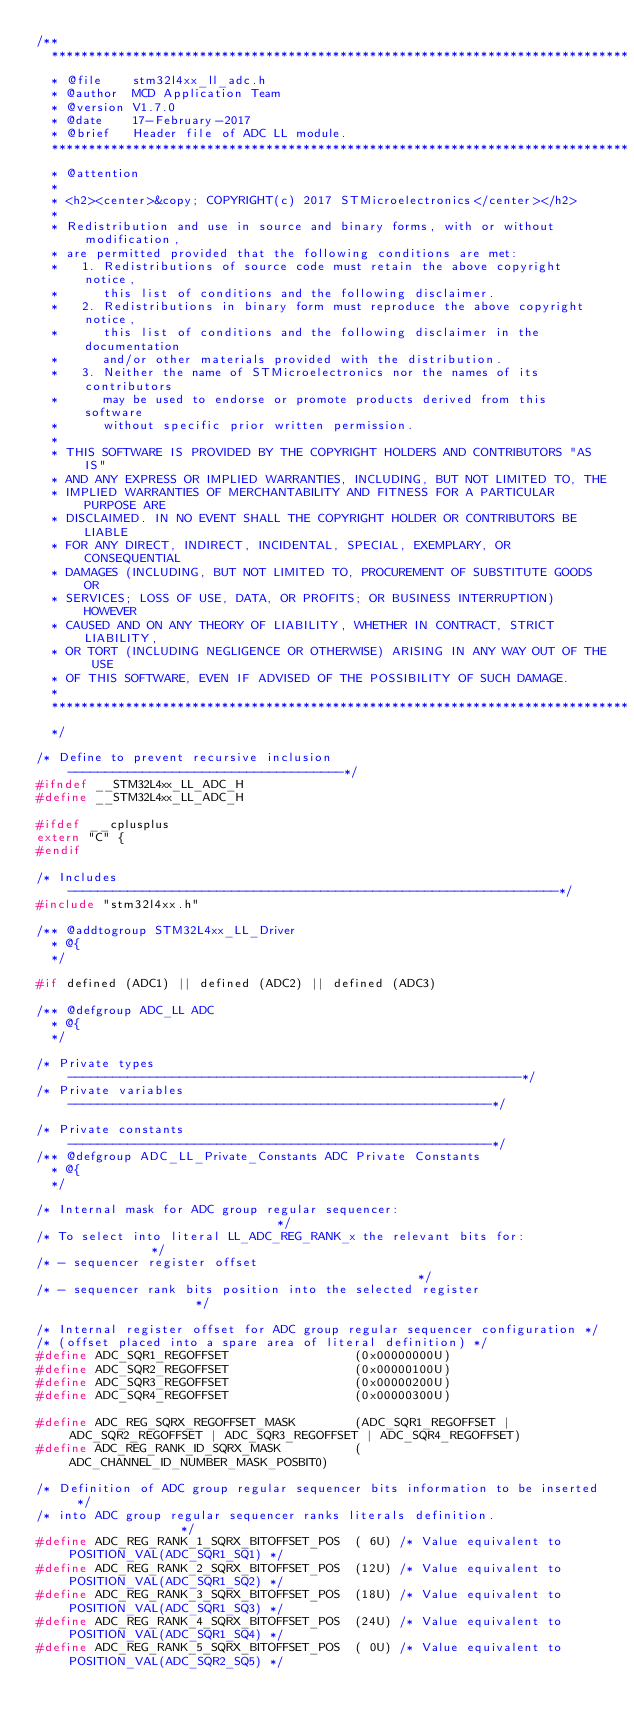Convert code to text. <code><loc_0><loc_0><loc_500><loc_500><_C_>/**
  ******************************************************************************
  * @file    stm32l4xx_ll_adc.h
  * @author  MCD Application Team
  * @version V1.7.0
  * @date    17-February-2017
  * @brief   Header file of ADC LL module.
  ******************************************************************************
  * @attention
  *
  * <h2><center>&copy; COPYRIGHT(c) 2017 STMicroelectronics</center></h2>
  *
  * Redistribution and use in source and binary forms, with or without modification,
  * are permitted provided that the following conditions are met:
  *   1. Redistributions of source code must retain the above copyright notice,
  *      this list of conditions and the following disclaimer.
  *   2. Redistributions in binary form must reproduce the above copyright notice,
  *      this list of conditions and the following disclaimer in the documentation
  *      and/or other materials provided with the distribution.
  *   3. Neither the name of STMicroelectronics nor the names of its contributors
  *      may be used to endorse or promote products derived from this software
  *      without specific prior written permission.
  *
  * THIS SOFTWARE IS PROVIDED BY THE COPYRIGHT HOLDERS AND CONTRIBUTORS "AS IS"
  * AND ANY EXPRESS OR IMPLIED WARRANTIES, INCLUDING, BUT NOT LIMITED TO, THE
  * IMPLIED WARRANTIES OF MERCHANTABILITY AND FITNESS FOR A PARTICULAR PURPOSE ARE
  * DISCLAIMED. IN NO EVENT SHALL THE COPYRIGHT HOLDER OR CONTRIBUTORS BE LIABLE
  * FOR ANY DIRECT, INDIRECT, INCIDENTAL, SPECIAL, EXEMPLARY, OR CONSEQUENTIAL
  * DAMAGES (INCLUDING, BUT NOT LIMITED TO, PROCUREMENT OF SUBSTITUTE GOODS OR
  * SERVICES; LOSS OF USE, DATA, OR PROFITS; OR BUSINESS INTERRUPTION) HOWEVER
  * CAUSED AND ON ANY THEORY OF LIABILITY, WHETHER IN CONTRACT, STRICT LIABILITY,
  * OR TORT (INCLUDING NEGLIGENCE OR OTHERWISE) ARISING IN ANY WAY OUT OF THE USE
  * OF THIS SOFTWARE, EVEN IF ADVISED OF THE POSSIBILITY OF SUCH DAMAGE.
  *
  ******************************************************************************
  */

/* Define to prevent recursive inclusion -------------------------------------*/
#ifndef __STM32L4xx_LL_ADC_H
#define __STM32L4xx_LL_ADC_H

#ifdef __cplusplus
extern "C" {
#endif

/* Includes ------------------------------------------------------------------*/
#include "stm32l4xx.h"

/** @addtogroup STM32L4xx_LL_Driver
  * @{
  */

#if defined (ADC1) || defined (ADC2) || defined (ADC3)

/** @defgroup ADC_LL ADC
  * @{
  */

/* Private types -------------------------------------------------------------*/
/* Private variables ---------------------------------------------------------*/

/* Private constants ---------------------------------------------------------*/
/** @defgroup ADC_LL_Private_Constants ADC Private Constants
  * @{
  */

/* Internal mask for ADC group regular sequencer:                             */
/* To select into literal LL_ADC_REG_RANK_x the relevant bits for:            */
/* - sequencer register offset                                                */
/* - sequencer rank bits position into the selected register                  */

/* Internal register offset for ADC group regular sequencer configuration */
/* (offset placed into a spare area of literal definition) */
#define ADC_SQR1_REGOFFSET                 (0x00000000U)
#define ADC_SQR2_REGOFFSET                 (0x00000100U)
#define ADC_SQR3_REGOFFSET                 (0x00000200U)
#define ADC_SQR4_REGOFFSET                 (0x00000300U)

#define ADC_REG_SQRX_REGOFFSET_MASK        (ADC_SQR1_REGOFFSET | ADC_SQR2_REGOFFSET | ADC_SQR3_REGOFFSET | ADC_SQR4_REGOFFSET)
#define ADC_REG_RANK_ID_SQRX_MASK          (ADC_CHANNEL_ID_NUMBER_MASK_POSBIT0)

/* Definition of ADC group regular sequencer bits information to be inserted  */
/* into ADC group regular sequencer ranks literals definition.                */
#define ADC_REG_RANK_1_SQRX_BITOFFSET_POS  ( 6U) /* Value equivalent to POSITION_VAL(ADC_SQR1_SQ1) */
#define ADC_REG_RANK_2_SQRX_BITOFFSET_POS  (12U) /* Value equivalent to POSITION_VAL(ADC_SQR1_SQ2) */
#define ADC_REG_RANK_3_SQRX_BITOFFSET_POS  (18U) /* Value equivalent to POSITION_VAL(ADC_SQR1_SQ3) */
#define ADC_REG_RANK_4_SQRX_BITOFFSET_POS  (24U) /* Value equivalent to POSITION_VAL(ADC_SQR1_SQ4) */
#define ADC_REG_RANK_5_SQRX_BITOFFSET_POS  ( 0U) /* Value equivalent to POSITION_VAL(ADC_SQR2_SQ5) */</code> 